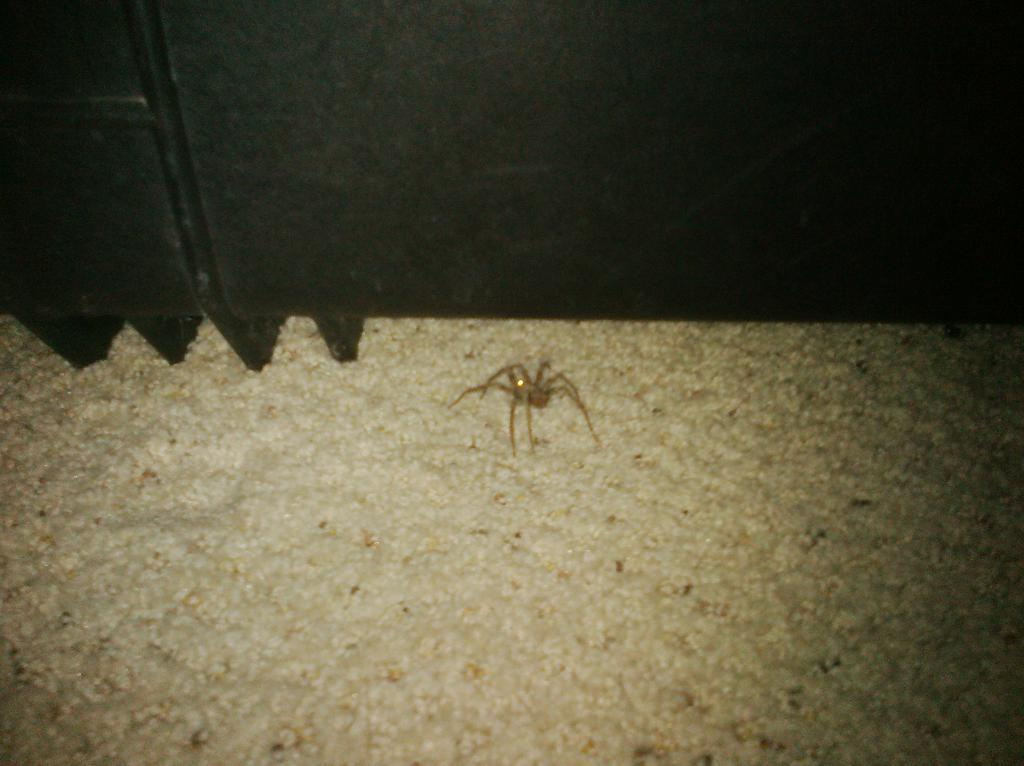What type of animal can be seen in the image? There is a spider in the image. What is the color of the spider? The spider is cream colored. What other object can be seen in the image besides the spider? There is a black object in the image. What type of toys can be seen in the image? There are no toys present in the image. What is the minute detail that can be observed on the spider's legs? The provided facts do not mention any minute details on the spider's legs. 